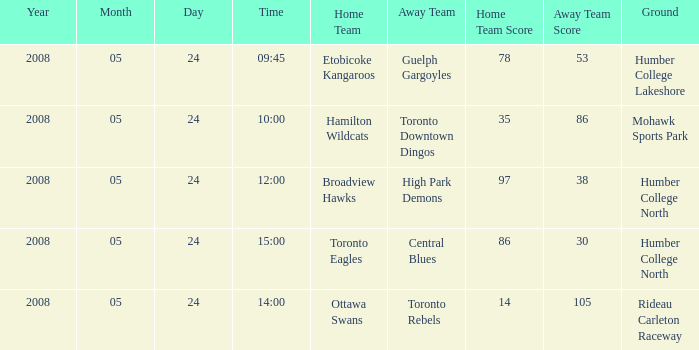Who was the home team of the game at the time of 14:00? Ottawa Swans. 